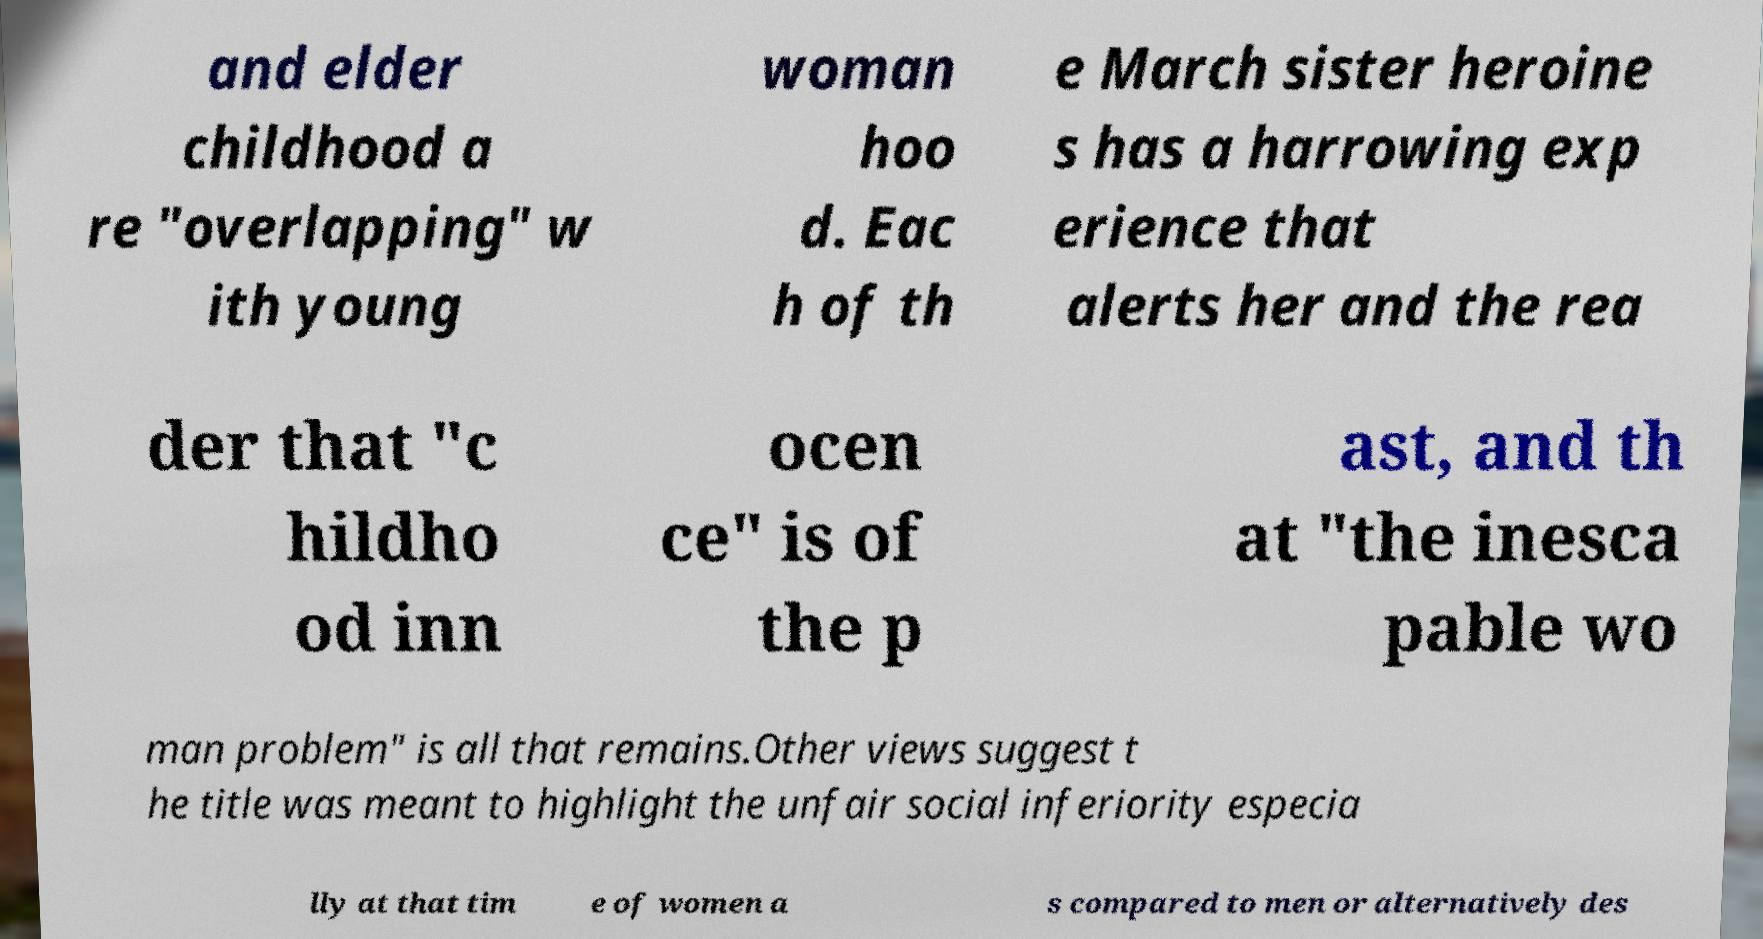Could you extract and type out the text from this image? and elder childhood a re "overlapping" w ith young woman hoo d. Eac h of th e March sister heroine s has a harrowing exp erience that alerts her and the rea der that "c hildho od inn ocen ce" is of the p ast, and th at "the inesca pable wo man problem" is all that remains.Other views suggest t he title was meant to highlight the unfair social inferiority especia lly at that tim e of women a s compared to men or alternatively des 